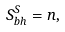<formula> <loc_0><loc_0><loc_500><loc_500>S _ { b h } ^ { S } = n ,</formula> 